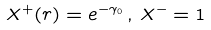Convert formula to latex. <formula><loc_0><loc_0><loc_500><loc_500>X ^ { + } ( r ) = e ^ { - \gamma _ { 0 } } \, , \, X ^ { - } = 1</formula> 